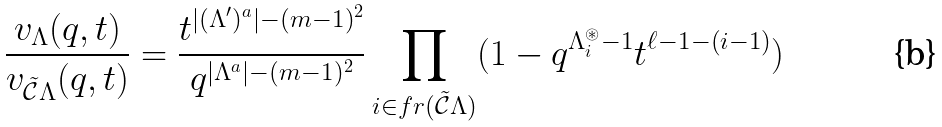Convert formula to latex. <formula><loc_0><loc_0><loc_500><loc_500>\frac { v _ { \Lambda } ( q , t ) } { v _ { \mathcal { \tilde { C } } \Lambda } ( q , t ) } = \frac { t ^ { | ( \Lambda ^ { \prime } ) ^ { a } | - ( m - 1 ) ^ { 2 } } } { q ^ { | \Lambda ^ { a } | - ( m - 1 ) ^ { 2 } } } \prod _ { i \in f r ( \tilde { \mathcal { C } } \Lambda ) } ( 1 - q ^ { \Lambda _ { i } ^ { \circledast } - 1 } t ^ { \ell - 1 - ( i - 1 ) } )</formula> 